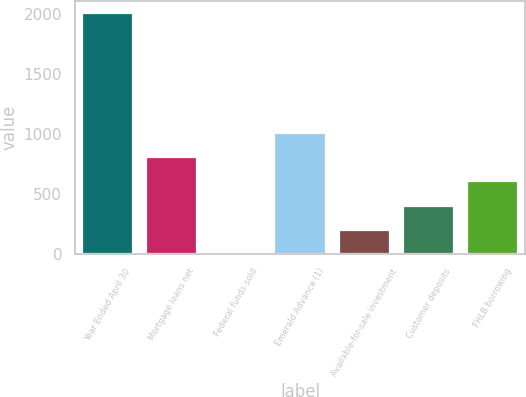Convert chart to OTSL. <chart><loc_0><loc_0><loc_500><loc_500><bar_chart><fcel>Year Ended April 30<fcel>Mortgage loans net<fcel>Federal funds sold<fcel>Emerald Advance (1)<fcel>Available-for-sale investment<fcel>Customer deposits<fcel>FHLB borrowing<nl><fcel>2010<fcel>804.05<fcel>0.09<fcel>1005.04<fcel>201.08<fcel>402.07<fcel>603.06<nl></chart> 